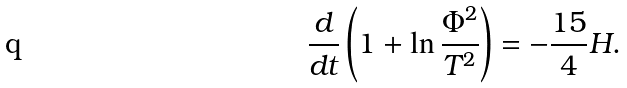Convert formula to latex. <formula><loc_0><loc_0><loc_500><loc_500>\frac { d } { d t } \left ( 1 + \ln \frac { \Phi ^ { 2 } } { T ^ { 2 } } \right ) = - \frac { 1 5 } { 4 } H .</formula> 